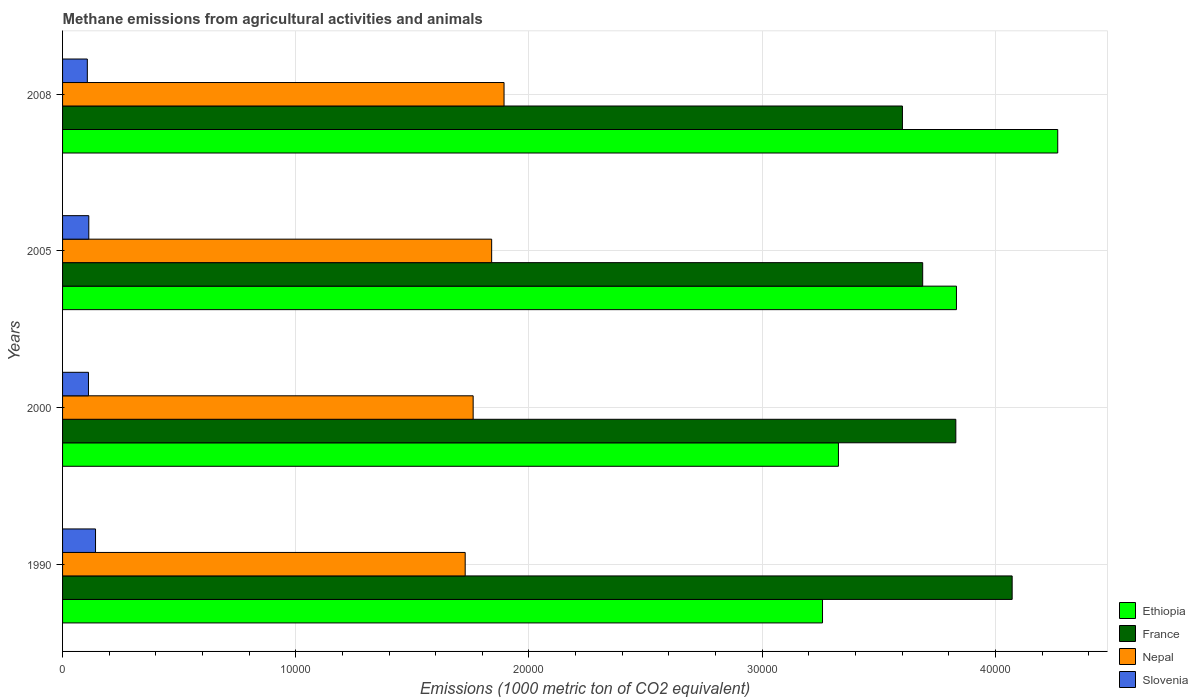Are the number of bars per tick equal to the number of legend labels?
Keep it short and to the point. Yes. What is the amount of methane emitted in France in 2005?
Provide a succinct answer. 3.69e+04. Across all years, what is the maximum amount of methane emitted in France?
Offer a very short reply. 4.07e+04. Across all years, what is the minimum amount of methane emitted in France?
Provide a short and direct response. 3.60e+04. In which year was the amount of methane emitted in Nepal maximum?
Provide a short and direct response. 2008. What is the total amount of methane emitted in Nepal in the graph?
Keep it short and to the point. 7.22e+04. What is the difference between the amount of methane emitted in Ethiopia in 2000 and that in 2005?
Offer a terse response. -5061. What is the difference between the amount of methane emitted in Ethiopia in 1990 and the amount of methane emitted in Slovenia in 2005?
Ensure brevity in your answer.  3.15e+04. What is the average amount of methane emitted in Slovenia per year?
Your answer should be compact. 1177.72. In the year 2008, what is the difference between the amount of methane emitted in Nepal and amount of methane emitted in Slovenia?
Keep it short and to the point. 1.79e+04. What is the ratio of the amount of methane emitted in France in 2000 to that in 2008?
Offer a very short reply. 1.06. Is the amount of methane emitted in Slovenia in 2000 less than that in 2005?
Offer a very short reply. Yes. Is the difference between the amount of methane emitted in Nepal in 2000 and 2008 greater than the difference between the amount of methane emitted in Slovenia in 2000 and 2008?
Give a very brief answer. No. What is the difference between the highest and the second highest amount of methane emitted in Slovenia?
Ensure brevity in your answer.  288.9. What is the difference between the highest and the lowest amount of methane emitted in Slovenia?
Provide a succinct answer. 351.7. What does the 4th bar from the top in 2000 represents?
Give a very brief answer. Ethiopia. What does the 4th bar from the bottom in 1990 represents?
Your answer should be very brief. Slovenia. How many years are there in the graph?
Keep it short and to the point. 4. Are the values on the major ticks of X-axis written in scientific E-notation?
Your answer should be compact. No. Does the graph contain any zero values?
Provide a succinct answer. No. Where does the legend appear in the graph?
Keep it short and to the point. Bottom right. How many legend labels are there?
Offer a terse response. 4. What is the title of the graph?
Your answer should be compact. Methane emissions from agricultural activities and animals. What is the label or title of the X-axis?
Provide a short and direct response. Emissions (1000 metric ton of CO2 equivalent). What is the Emissions (1000 metric ton of CO2 equivalent) in Ethiopia in 1990?
Your response must be concise. 3.26e+04. What is the Emissions (1000 metric ton of CO2 equivalent) in France in 1990?
Provide a short and direct response. 4.07e+04. What is the Emissions (1000 metric ton of CO2 equivalent) of Nepal in 1990?
Your response must be concise. 1.73e+04. What is the Emissions (1000 metric ton of CO2 equivalent) in Slovenia in 1990?
Make the answer very short. 1413.5. What is the Emissions (1000 metric ton of CO2 equivalent) in Ethiopia in 2000?
Your answer should be very brief. 3.33e+04. What is the Emissions (1000 metric ton of CO2 equivalent) in France in 2000?
Keep it short and to the point. 3.83e+04. What is the Emissions (1000 metric ton of CO2 equivalent) of Nepal in 2000?
Provide a short and direct response. 1.76e+04. What is the Emissions (1000 metric ton of CO2 equivalent) in Slovenia in 2000?
Offer a very short reply. 1111. What is the Emissions (1000 metric ton of CO2 equivalent) in Ethiopia in 2005?
Your answer should be compact. 3.83e+04. What is the Emissions (1000 metric ton of CO2 equivalent) in France in 2005?
Make the answer very short. 3.69e+04. What is the Emissions (1000 metric ton of CO2 equivalent) of Nepal in 2005?
Offer a very short reply. 1.84e+04. What is the Emissions (1000 metric ton of CO2 equivalent) of Slovenia in 2005?
Make the answer very short. 1124.6. What is the Emissions (1000 metric ton of CO2 equivalent) of Ethiopia in 2008?
Your answer should be compact. 4.27e+04. What is the Emissions (1000 metric ton of CO2 equivalent) of France in 2008?
Provide a short and direct response. 3.60e+04. What is the Emissions (1000 metric ton of CO2 equivalent) of Nepal in 2008?
Provide a short and direct response. 1.89e+04. What is the Emissions (1000 metric ton of CO2 equivalent) of Slovenia in 2008?
Give a very brief answer. 1061.8. Across all years, what is the maximum Emissions (1000 metric ton of CO2 equivalent) in Ethiopia?
Provide a succinct answer. 4.27e+04. Across all years, what is the maximum Emissions (1000 metric ton of CO2 equivalent) in France?
Provide a succinct answer. 4.07e+04. Across all years, what is the maximum Emissions (1000 metric ton of CO2 equivalent) in Nepal?
Ensure brevity in your answer.  1.89e+04. Across all years, what is the maximum Emissions (1000 metric ton of CO2 equivalent) in Slovenia?
Your response must be concise. 1413.5. Across all years, what is the minimum Emissions (1000 metric ton of CO2 equivalent) of Ethiopia?
Offer a very short reply. 3.26e+04. Across all years, what is the minimum Emissions (1000 metric ton of CO2 equivalent) of France?
Your answer should be very brief. 3.60e+04. Across all years, what is the minimum Emissions (1000 metric ton of CO2 equivalent) in Nepal?
Offer a very short reply. 1.73e+04. Across all years, what is the minimum Emissions (1000 metric ton of CO2 equivalent) of Slovenia?
Your response must be concise. 1061.8. What is the total Emissions (1000 metric ton of CO2 equivalent) of Ethiopia in the graph?
Ensure brevity in your answer.  1.47e+05. What is the total Emissions (1000 metric ton of CO2 equivalent) of France in the graph?
Provide a short and direct response. 1.52e+05. What is the total Emissions (1000 metric ton of CO2 equivalent) of Nepal in the graph?
Provide a succinct answer. 7.22e+04. What is the total Emissions (1000 metric ton of CO2 equivalent) of Slovenia in the graph?
Keep it short and to the point. 4710.9. What is the difference between the Emissions (1000 metric ton of CO2 equivalent) of Ethiopia in 1990 and that in 2000?
Provide a succinct answer. -682.4. What is the difference between the Emissions (1000 metric ton of CO2 equivalent) of France in 1990 and that in 2000?
Ensure brevity in your answer.  2415.3. What is the difference between the Emissions (1000 metric ton of CO2 equivalent) in Nepal in 1990 and that in 2000?
Ensure brevity in your answer.  -341.8. What is the difference between the Emissions (1000 metric ton of CO2 equivalent) of Slovenia in 1990 and that in 2000?
Make the answer very short. 302.5. What is the difference between the Emissions (1000 metric ton of CO2 equivalent) of Ethiopia in 1990 and that in 2005?
Give a very brief answer. -5743.4. What is the difference between the Emissions (1000 metric ton of CO2 equivalent) of France in 1990 and that in 2005?
Your response must be concise. 3836.5. What is the difference between the Emissions (1000 metric ton of CO2 equivalent) in Nepal in 1990 and that in 2005?
Ensure brevity in your answer.  -1135.1. What is the difference between the Emissions (1000 metric ton of CO2 equivalent) in Slovenia in 1990 and that in 2005?
Offer a terse response. 288.9. What is the difference between the Emissions (1000 metric ton of CO2 equivalent) in Ethiopia in 1990 and that in 2008?
Keep it short and to the point. -1.01e+04. What is the difference between the Emissions (1000 metric ton of CO2 equivalent) in France in 1990 and that in 2008?
Make the answer very short. 4704.7. What is the difference between the Emissions (1000 metric ton of CO2 equivalent) in Nepal in 1990 and that in 2008?
Offer a very short reply. -1666.2. What is the difference between the Emissions (1000 metric ton of CO2 equivalent) of Slovenia in 1990 and that in 2008?
Keep it short and to the point. 351.7. What is the difference between the Emissions (1000 metric ton of CO2 equivalent) of Ethiopia in 2000 and that in 2005?
Provide a succinct answer. -5061. What is the difference between the Emissions (1000 metric ton of CO2 equivalent) of France in 2000 and that in 2005?
Provide a succinct answer. 1421.2. What is the difference between the Emissions (1000 metric ton of CO2 equivalent) of Nepal in 2000 and that in 2005?
Your answer should be very brief. -793.3. What is the difference between the Emissions (1000 metric ton of CO2 equivalent) of Ethiopia in 2000 and that in 2008?
Provide a succinct answer. -9403.7. What is the difference between the Emissions (1000 metric ton of CO2 equivalent) in France in 2000 and that in 2008?
Make the answer very short. 2289.4. What is the difference between the Emissions (1000 metric ton of CO2 equivalent) of Nepal in 2000 and that in 2008?
Your answer should be compact. -1324.4. What is the difference between the Emissions (1000 metric ton of CO2 equivalent) in Slovenia in 2000 and that in 2008?
Provide a succinct answer. 49.2. What is the difference between the Emissions (1000 metric ton of CO2 equivalent) of Ethiopia in 2005 and that in 2008?
Ensure brevity in your answer.  -4342.7. What is the difference between the Emissions (1000 metric ton of CO2 equivalent) of France in 2005 and that in 2008?
Offer a terse response. 868.2. What is the difference between the Emissions (1000 metric ton of CO2 equivalent) of Nepal in 2005 and that in 2008?
Offer a terse response. -531.1. What is the difference between the Emissions (1000 metric ton of CO2 equivalent) in Slovenia in 2005 and that in 2008?
Your response must be concise. 62.8. What is the difference between the Emissions (1000 metric ton of CO2 equivalent) of Ethiopia in 1990 and the Emissions (1000 metric ton of CO2 equivalent) of France in 2000?
Offer a very short reply. -5716.5. What is the difference between the Emissions (1000 metric ton of CO2 equivalent) of Ethiopia in 1990 and the Emissions (1000 metric ton of CO2 equivalent) of Nepal in 2000?
Make the answer very short. 1.50e+04. What is the difference between the Emissions (1000 metric ton of CO2 equivalent) of Ethiopia in 1990 and the Emissions (1000 metric ton of CO2 equivalent) of Slovenia in 2000?
Offer a terse response. 3.15e+04. What is the difference between the Emissions (1000 metric ton of CO2 equivalent) in France in 1990 and the Emissions (1000 metric ton of CO2 equivalent) in Nepal in 2000?
Your answer should be very brief. 2.31e+04. What is the difference between the Emissions (1000 metric ton of CO2 equivalent) in France in 1990 and the Emissions (1000 metric ton of CO2 equivalent) in Slovenia in 2000?
Your answer should be very brief. 3.96e+04. What is the difference between the Emissions (1000 metric ton of CO2 equivalent) of Nepal in 1990 and the Emissions (1000 metric ton of CO2 equivalent) of Slovenia in 2000?
Ensure brevity in your answer.  1.62e+04. What is the difference between the Emissions (1000 metric ton of CO2 equivalent) of Ethiopia in 1990 and the Emissions (1000 metric ton of CO2 equivalent) of France in 2005?
Give a very brief answer. -4295.3. What is the difference between the Emissions (1000 metric ton of CO2 equivalent) in Ethiopia in 1990 and the Emissions (1000 metric ton of CO2 equivalent) in Nepal in 2005?
Give a very brief answer. 1.42e+04. What is the difference between the Emissions (1000 metric ton of CO2 equivalent) of Ethiopia in 1990 and the Emissions (1000 metric ton of CO2 equivalent) of Slovenia in 2005?
Give a very brief answer. 3.15e+04. What is the difference between the Emissions (1000 metric ton of CO2 equivalent) in France in 1990 and the Emissions (1000 metric ton of CO2 equivalent) in Nepal in 2005?
Your answer should be very brief. 2.23e+04. What is the difference between the Emissions (1000 metric ton of CO2 equivalent) in France in 1990 and the Emissions (1000 metric ton of CO2 equivalent) in Slovenia in 2005?
Offer a very short reply. 3.96e+04. What is the difference between the Emissions (1000 metric ton of CO2 equivalent) in Nepal in 1990 and the Emissions (1000 metric ton of CO2 equivalent) in Slovenia in 2005?
Offer a very short reply. 1.61e+04. What is the difference between the Emissions (1000 metric ton of CO2 equivalent) of Ethiopia in 1990 and the Emissions (1000 metric ton of CO2 equivalent) of France in 2008?
Your answer should be very brief. -3427.1. What is the difference between the Emissions (1000 metric ton of CO2 equivalent) in Ethiopia in 1990 and the Emissions (1000 metric ton of CO2 equivalent) in Nepal in 2008?
Your answer should be compact. 1.37e+04. What is the difference between the Emissions (1000 metric ton of CO2 equivalent) in Ethiopia in 1990 and the Emissions (1000 metric ton of CO2 equivalent) in Slovenia in 2008?
Provide a short and direct response. 3.15e+04. What is the difference between the Emissions (1000 metric ton of CO2 equivalent) in France in 1990 and the Emissions (1000 metric ton of CO2 equivalent) in Nepal in 2008?
Offer a terse response. 2.18e+04. What is the difference between the Emissions (1000 metric ton of CO2 equivalent) in France in 1990 and the Emissions (1000 metric ton of CO2 equivalent) in Slovenia in 2008?
Keep it short and to the point. 3.97e+04. What is the difference between the Emissions (1000 metric ton of CO2 equivalent) in Nepal in 1990 and the Emissions (1000 metric ton of CO2 equivalent) in Slovenia in 2008?
Your answer should be compact. 1.62e+04. What is the difference between the Emissions (1000 metric ton of CO2 equivalent) of Ethiopia in 2000 and the Emissions (1000 metric ton of CO2 equivalent) of France in 2005?
Give a very brief answer. -3612.9. What is the difference between the Emissions (1000 metric ton of CO2 equivalent) of Ethiopia in 2000 and the Emissions (1000 metric ton of CO2 equivalent) of Nepal in 2005?
Make the answer very short. 1.49e+04. What is the difference between the Emissions (1000 metric ton of CO2 equivalent) of Ethiopia in 2000 and the Emissions (1000 metric ton of CO2 equivalent) of Slovenia in 2005?
Your answer should be very brief. 3.21e+04. What is the difference between the Emissions (1000 metric ton of CO2 equivalent) in France in 2000 and the Emissions (1000 metric ton of CO2 equivalent) in Nepal in 2005?
Offer a terse response. 1.99e+04. What is the difference between the Emissions (1000 metric ton of CO2 equivalent) of France in 2000 and the Emissions (1000 metric ton of CO2 equivalent) of Slovenia in 2005?
Make the answer very short. 3.72e+04. What is the difference between the Emissions (1000 metric ton of CO2 equivalent) of Nepal in 2000 and the Emissions (1000 metric ton of CO2 equivalent) of Slovenia in 2005?
Provide a short and direct response. 1.65e+04. What is the difference between the Emissions (1000 metric ton of CO2 equivalent) of Ethiopia in 2000 and the Emissions (1000 metric ton of CO2 equivalent) of France in 2008?
Provide a succinct answer. -2744.7. What is the difference between the Emissions (1000 metric ton of CO2 equivalent) of Ethiopia in 2000 and the Emissions (1000 metric ton of CO2 equivalent) of Nepal in 2008?
Your answer should be very brief. 1.43e+04. What is the difference between the Emissions (1000 metric ton of CO2 equivalent) in Ethiopia in 2000 and the Emissions (1000 metric ton of CO2 equivalent) in Slovenia in 2008?
Ensure brevity in your answer.  3.22e+04. What is the difference between the Emissions (1000 metric ton of CO2 equivalent) of France in 2000 and the Emissions (1000 metric ton of CO2 equivalent) of Nepal in 2008?
Ensure brevity in your answer.  1.94e+04. What is the difference between the Emissions (1000 metric ton of CO2 equivalent) in France in 2000 and the Emissions (1000 metric ton of CO2 equivalent) in Slovenia in 2008?
Your answer should be compact. 3.72e+04. What is the difference between the Emissions (1000 metric ton of CO2 equivalent) of Nepal in 2000 and the Emissions (1000 metric ton of CO2 equivalent) of Slovenia in 2008?
Provide a short and direct response. 1.65e+04. What is the difference between the Emissions (1000 metric ton of CO2 equivalent) of Ethiopia in 2005 and the Emissions (1000 metric ton of CO2 equivalent) of France in 2008?
Give a very brief answer. 2316.3. What is the difference between the Emissions (1000 metric ton of CO2 equivalent) in Ethiopia in 2005 and the Emissions (1000 metric ton of CO2 equivalent) in Nepal in 2008?
Make the answer very short. 1.94e+04. What is the difference between the Emissions (1000 metric ton of CO2 equivalent) of Ethiopia in 2005 and the Emissions (1000 metric ton of CO2 equivalent) of Slovenia in 2008?
Give a very brief answer. 3.73e+04. What is the difference between the Emissions (1000 metric ton of CO2 equivalent) of France in 2005 and the Emissions (1000 metric ton of CO2 equivalent) of Nepal in 2008?
Keep it short and to the point. 1.80e+04. What is the difference between the Emissions (1000 metric ton of CO2 equivalent) in France in 2005 and the Emissions (1000 metric ton of CO2 equivalent) in Slovenia in 2008?
Offer a very short reply. 3.58e+04. What is the difference between the Emissions (1000 metric ton of CO2 equivalent) of Nepal in 2005 and the Emissions (1000 metric ton of CO2 equivalent) of Slovenia in 2008?
Offer a very short reply. 1.73e+04. What is the average Emissions (1000 metric ton of CO2 equivalent) in Ethiopia per year?
Keep it short and to the point. 3.67e+04. What is the average Emissions (1000 metric ton of CO2 equivalent) of France per year?
Make the answer very short. 3.80e+04. What is the average Emissions (1000 metric ton of CO2 equivalent) of Nepal per year?
Give a very brief answer. 1.80e+04. What is the average Emissions (1000 metric ton of CO2 equivalent) of Slovenia per year?
Ensure brevity in your answer.  1177.72. In the year 1990, what is the difference between the Emissions (1000 metric ton of CO2 equivalent) of Ethiopia and Emissions (1000 metric ton of CO2 equivalent) of France?
Your answer should be very brief. -8131.8. In the year 1990, what is the difference between the Emissions (1000 metric ton of CO2 equivalent) of Ethiopia and Emissions (1000 metric ton of CO2 equivalent) of Nepal?
Provide a succinct answer. 1.53e+04. In the year 1990, what is the difference between the Emissions (1000 metric ton of CO2 equivalent) of Ethiopia and Emissions (1000 metric ton of CO2 equivalent) of Slovenia?
Your answer should be very brief. 3.12e+04. In the year 1990, what is the difference between the Emissions (1000 metric ton of CO2 equivalent) of France and Emissions (1000 metric ton of CO2 equivalent) of Nepal?
Your answer should be very brief. 2.35e+04. In the year 1990, what is the difference between the Emissions (1000 metric ton of CO2 equivalent) of France and Emissions (1000 metric ton of CO2 equivalent) of Slovenia?
Keep it short and to the point. 3.93e+04. In the year 1990, what is the difference between the Emissions (1000 metric ton of CO2 equivalent) in Nepal and Emissions (1000 metric ton of CO2 equivalent) in Slovenia?
Offer a very short reply. 1.59e+04. In the year 2000, what is the difference between the Emissions (1000 metric ton of CO2 equivalent) in Ethiopia and Emissions (1000 metric ton of CO2 equivalent) in France?
Ensure brevity in your answer.  -5034.1. In the year 2000, what is the difference between the Emissions (1000 metric ton of CO2 equivalent) of Ethiopia and Emissions (1000 metric ton of CO2 equivalent) of Nepal?
Offer a terse response. 1.57e+04. In the year 2000, what is the difference between the Emissions (1000 metric ton of CO2 equivalent) in Ethiopia and Emissions (1000 metric ton of CO2 equivalent) in Slovenia?
Offer a terse response. 3.22e+04. In the year 2000, what is the difference between the Emissions (1000 metric ton of CO2 equivalent) of France and Emissions (1000 metric ton of CO2 equivalent) of Nepal?
Keep it short and to the point. 2.07e+04. In the year 2000, what is the difference between the Emissions (1000 metric ton of CO2 equivalent) in France and Emissions (1000 metric ton of CO2 equivalent) in Slovenia?
Keep it short and to the point. 3.72e+04. In the year 2000, what is the difference between the Emissions (1000 metric ton of CO2 equivalent) in Nepal and Emissions (1000 metric ton of CO2 equivalent) in Slovenia?
Ensure brevity in your answer.  1.65e+04. In the year 2005, what is the difference between the Emissions (1000 metric ton of CO2 equivalent) in Ethiopia and Emissions (1000 metric ton of CO2 equivalent) in France?
Ensure brevity in your answer.  1448.1. In the year 2005, what is the difference between the Emissions (1000 metric ton of CO2 equivalent) in Ethiopia and Emissions (1000 metric ton of CO2 equivalent) in Nepal?
Ensure brevity in your answer.  1.99e+04. In the year 2005, what is the difference between the Emissions (1000 metric ton of CO2 equivalent) of Ethiopia and Emissions (1000 metric ton of CO2 equivalent) of Slovenia?
Your response must be concise. 3.72e+04. In the year 2005, what is the difference between the Emissions (1000 metric ton of CO2 equivalent) of France and Emissions (1000 metric ton of CO2 equivalent) of Nepal?
Ensure brevity in your answer.  1.85e+04. In the year 2005, what is the difference between the Emissions (1000 metric ton of CO2 equivalent) of France and Emissions (1000 metric ton of CO2 equivalent) of Slovenia?
Give a very brief answer. 3.58e+04. In the year 2005, what is the difference between the Emissions (1000 metric ton of CO2 equivalent) in Nepal and Emissions (1000 metric ton of CO2 equivalent) in Slovenia?
Offer a very short reply. 1.73e+04. In the year 2008, what is the difference between the Emissions (1000 metric ton of CO2 equivalent) in Ethiopia and Emissions (1000 metric ton of CO2 equivalent) in France?
Ensure brevity in your answer.  6659. In the year 2008, what is the difference between the Emissions (1000 metric ton of CO2 equivalent) in Ethiopia and Emissions (1000 metric ton of CO2 equivalent) in Nepal?
Keep it short and to the point. 2.37e+04. In the year 2008, what is the difference between the Emissions (1000 metric ton of CO2 equivalent) of Ethiopia and Emissions (1000 metric ton of CO2 equivalent) of Slovenia?
Give a very brief answer. 4.16e+04. In the year 2008, what is the difference between the Emissions (1000 metric ton of CO2 equivalent) in France and Emissions (1000 metric ton of CO2 equivalent) in Nepal?
Give a very brief answer. 1.71e+04. In the year 2008, what is the difference between the Emissions (1000 metric ton of CO2 equivalent) in France and Emissions (1000 metric ton of CO2 equivalent) in Slovenia?
Your response must be concise. 3.50e+04. In the year 2008, what is the difference between the Emissions (1000 metric ton of CO2 equivalent) in Nepal and Emissions (1000 metric ton of CO2 equivalent) in Slovenia?
Offer a very short reply. 1.79e+04. What is the ratio of the Emissions (1000 metric ton of CO2 equivalent) of Ethiopia in 1990 to that in 2000?
Offer a very short reply. 0.98. What is the ratio of the Emissions (1000 metric ton of CO2 equivalent) of France in 1990 to that in 2000?
Your response must be concise. 1.06. What is the ratio of the Emissions (1000 metric ton of CO2 equivalent) in Nepal in 1990 to that in 2000?
Offer a very short reply. 0.98. What is the ratio of the Emissions (1000 metric ton of CO2 equivalent) in Slovenia in 1990 to that in 2000?
Your answer should be compact. 1.27. What is the ratio of the Emissions (1000 metric ton of CO2 equivalent) in Ethiopia in 1990 to that in 2005?
Keep it short and to the point. 0.85. What is the ratio of the Emissions (1000 metric ton of CO2 equivalent) of France in 1990 to that in 2005?
Provide a short and direct response. 1.1. What is the ratio of the Emissions (1000 metric ton of CO2 equivalent) in Nepal in 1990 to that in 2005?
Give a very brief answer. 0.94. What is the ratio of the Emissions (1000 metric ton of CO2 equivalent) in Slovenia in 1990 to that in 2005?
Your answer should be very brief. 1.26. What is the ratio of the Emissions (1000 metric ton of CO2 equivalent) of Ethiopia in 1990 to that in 2008?
Keep it short and to the point. 0.76. What is the ratio of the Emissions (1000 metric ton of CO2 equivalent) in France in 1990 to that in 2008?
Offer a terse response. 1.13. What is the ratio of the Emissions (1000 metric ton of CO2 equivalent) of Nepal in 1990 to that in 2008?
Your answer should be compact. 0.91. What is the ratio of the Emissions (1000 metric ton of CO2 equivalent) of Slovenia in 1990 to that in 2008?
Offer a terse response. 1.33. What is the ratio of the Emissions (1000 metric ton of CO2 equivalent) of Ethiopia in 2000 to that in 2005?
Offer a terse response. 0.87. What is the ratio of the Emissions (1000 metric ton of CO2 equivalent) of Nepal in 2000 to that in 2005?
Your response must be concise. 0.96. What is the ratio of the Emissions (1000 metric ton of CO2 equivalent) in Slovenia in 2000 to that in 2005?
Make the answer very short. 0.99. What is the ratio of the Emissions (1000 metric ton of CO2 equivalent) of Ethiopia in 2000 to that in 2008?
Provide a short and direct response. 0.78. What is the ratio of the Emissions (1000 metric ton of CO2 equivalent) of France in 2000 to that in 2008?
Provide a short and direct response. 1.06. What is the ratio of the Emissions (1000 metric ton of CO2 equivalent) of Nepal in 2000 to that in 2008?
Your answer should be very brief. 0.93. What is the ratio of the Emissions (1000 metric ton of CO2 equivalent) of Slovenia in 2000 to that in 2008?
Provide a short and direct response. 1.05. What is the ratio of the Emissions (1000 metric ton of CO2 equivalent) in Ethiopia in 2005 to that in 2008?
Provide a short and direct response. 0.9. What is the ratio of the Emissions (1000 metric ton of CO2 equivalent) in France in 2005 to that in 2008?
Your answer should be very brief. 1.02. What is the ratio of the Emissions (1000 metric ton of CO2 equivalent) in Nepal in 2005 to that in 2008?
Your answer should be very brief. 0.97. What is the ratio of the Emissions (1000 metric ton of CO2 equivalent) in Slovenia in 2005 to that in 2008?
Provide a short and direct response. 1.06. What is the difference between the highest and the second highest Emissions (1000 metric ton of CO2 equivalent) of Ethiopia?
Offer a terse response. 4342.7. What is the difference between the highest and the second highest Emissions (1000 metric ton of CO2 equivalent) in France?
Your answer should be very brief. 2415.3. What is the difference between the highest and the second highest Emissions (1000 metric ton of CO2 equivalent) in Nepal?
Provide a short and direct response. 531.1. What is the difference between the highest and the second highest Emissions (1000 metric ton of CO2 equivalent) in Slovenia?
Your response must be concise. 288.9. What is the difference between the highest and the lowest Emissions (1000 metric ton of CO2 equivalent) in Ethiopia?
Keep it short and to the point. 1.01e+04. What is the difference between the highest and the lowest Emissions (1000 metric ton of CO2 equivalent) of France?
Give a very brief answer. 4704.7. What is the difference between the highest and the lowest Emissions (1000 metric ton of CO2 equivalent) of Nepal?
Ensure brevity in your answer.  1666.2. What is the difference between the highest and the lowest Emissions (1000 metric ton of CO2 equivalent) in Slovenia?
Ensure brevity in your answer.  351.7. 